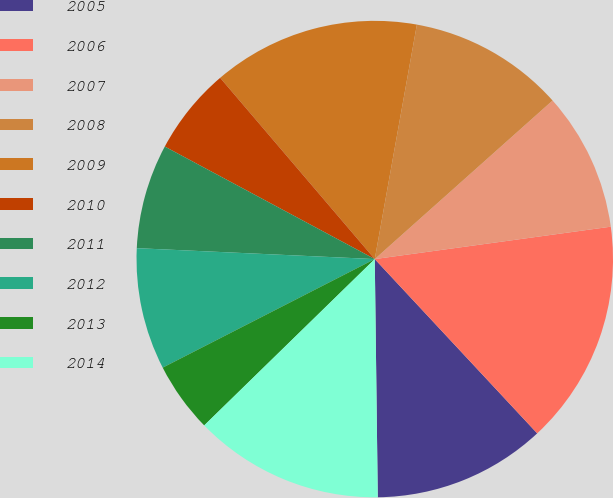Convert chart to OTSL. <chart><loc_0><loc_0><loc_500><loc_500><pie_chart><fcel>2005<fcel>2006<fcel>2007<fcel>2008<fcel>2009<fcel>2010<fcel>2011<fcel>2012<fcel>2013<fcel>2014<nl><fcel>11.74%<fcel>15.23%<fcel>9.42%<fcel>10.58%<fcel>14.07%<fcel>5.93%<fcel>7.1%<fcel>8.26%<fcel>4.77%<fcel>12.9%<nl></chart> 